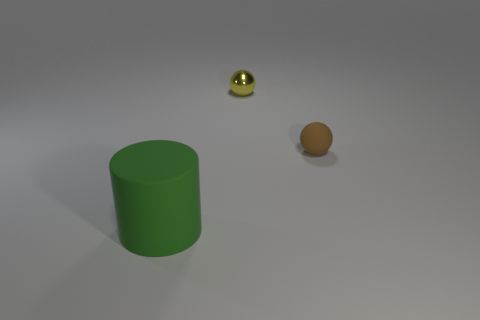Is there anything else that has the same size as the green rubber object?
Keep it short and to the point. No. Is there any other thing that is the same shape as the large green thing?
Provide a short and direct response. No. The tiny brown rubber thing has what shape?
Your answer should be very brief. Sphere. There is a yellow shiny thing; are there any big rubber things left of it?
Keep it short and to the point. Yes. Does the tiny yellow object have the same material as the thing that is in front of the matte ball?
Give a very brief answer. No. Is the shape of the tiny object that is on the right side of the small yellow metallic thing the same as  the metal thing?
Your answer should be very brief. Yes. What number of small balls are the same material as the big green object?
Your answer should be compact. 1. What number of things are matte objects that are to the right of the large green matte thing or big green rubber things?
Keep it short and to the point. 2. The green rubber cylinder is what size?
Provide a succinct answer. Large. What is the small thing on the left side of the rubber object behind the green rubber object made of?
Give a very brief answer. Metal. 